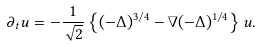<formula> <loc_0><loc_0><loc_500><loc_500>\partial _ { t } u = - \frac { 1 } { \sqrt { 2 } } \left \{ ( - \Delta ) ^ { 3 / 4 } - \nabla ( - \Delta ) ^ { 1 / 4 } \right \} u .</formula> 